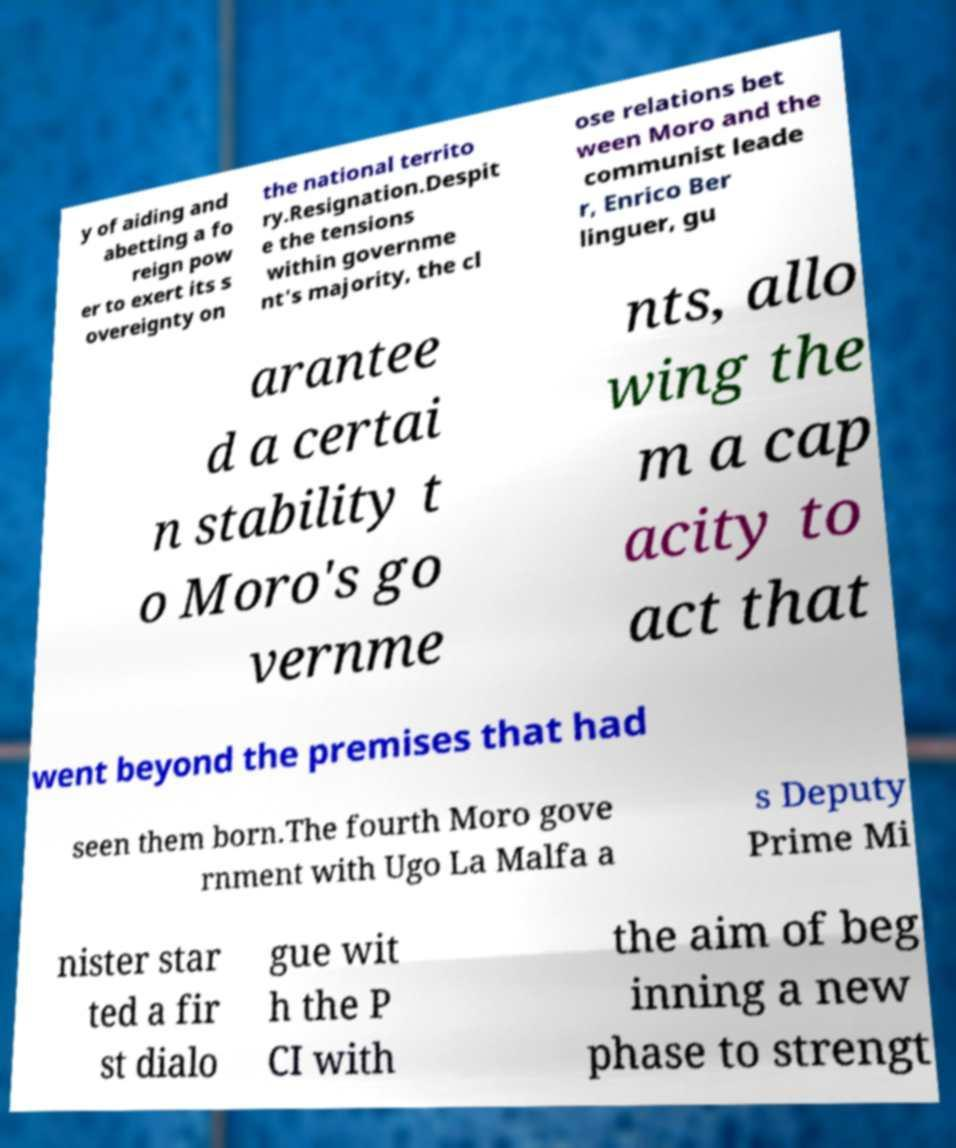Please identify and transcribe the text found in this image. y of aiding and abetting a fo reign pow er to exert its s overeignty on the national territo ry.Resignation.Despit e the tensions within governme nt's majority, the cl ose relations bet ween Moro and the communist leade r, Enrico Ber linguer, gu arantee d a certai n stability t o Moro's go vernme nts, allo wing the m a cap acity to act that went beyond the premises that had seen them born.The fourth Moro gove rnment with Ugo La Malfa a s Deputy Prime Mi nister star ted a fir st dialo gue wit h the P CI with the aim of beg inning a new phase to strengt 